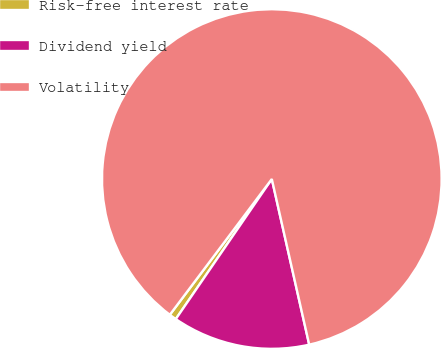Convert chart to OTSL. <chart><loc_0><loc_0><loc_500><loc_500><pie_chart><fcel>Risk-free interest rate<fcel>Dividend yield<fcel>Volatility<nl><fcel>0.69%<fcel>13.1%<fcel>86.21%<nl></chart> 